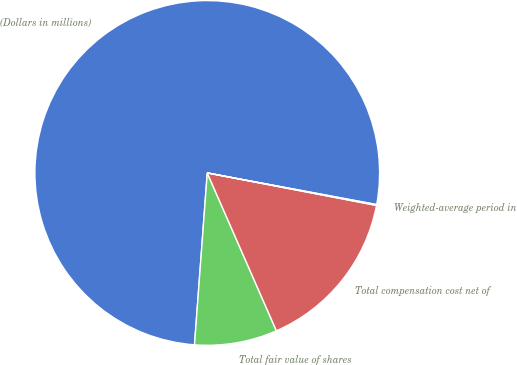Convert chart to OTSL. <chart><loc_0><loc_0><loc_500><loc_500><pie_chart><fcel>(Dollars in millions)<fcel>Total fair value of shares<fcel>Total compensation cost net of<fcel>Weighted-average period in<nl><fcel>76.76%<fcel>7.75%<fcel>15.41%<fcel>0.08%<nl></chart> 